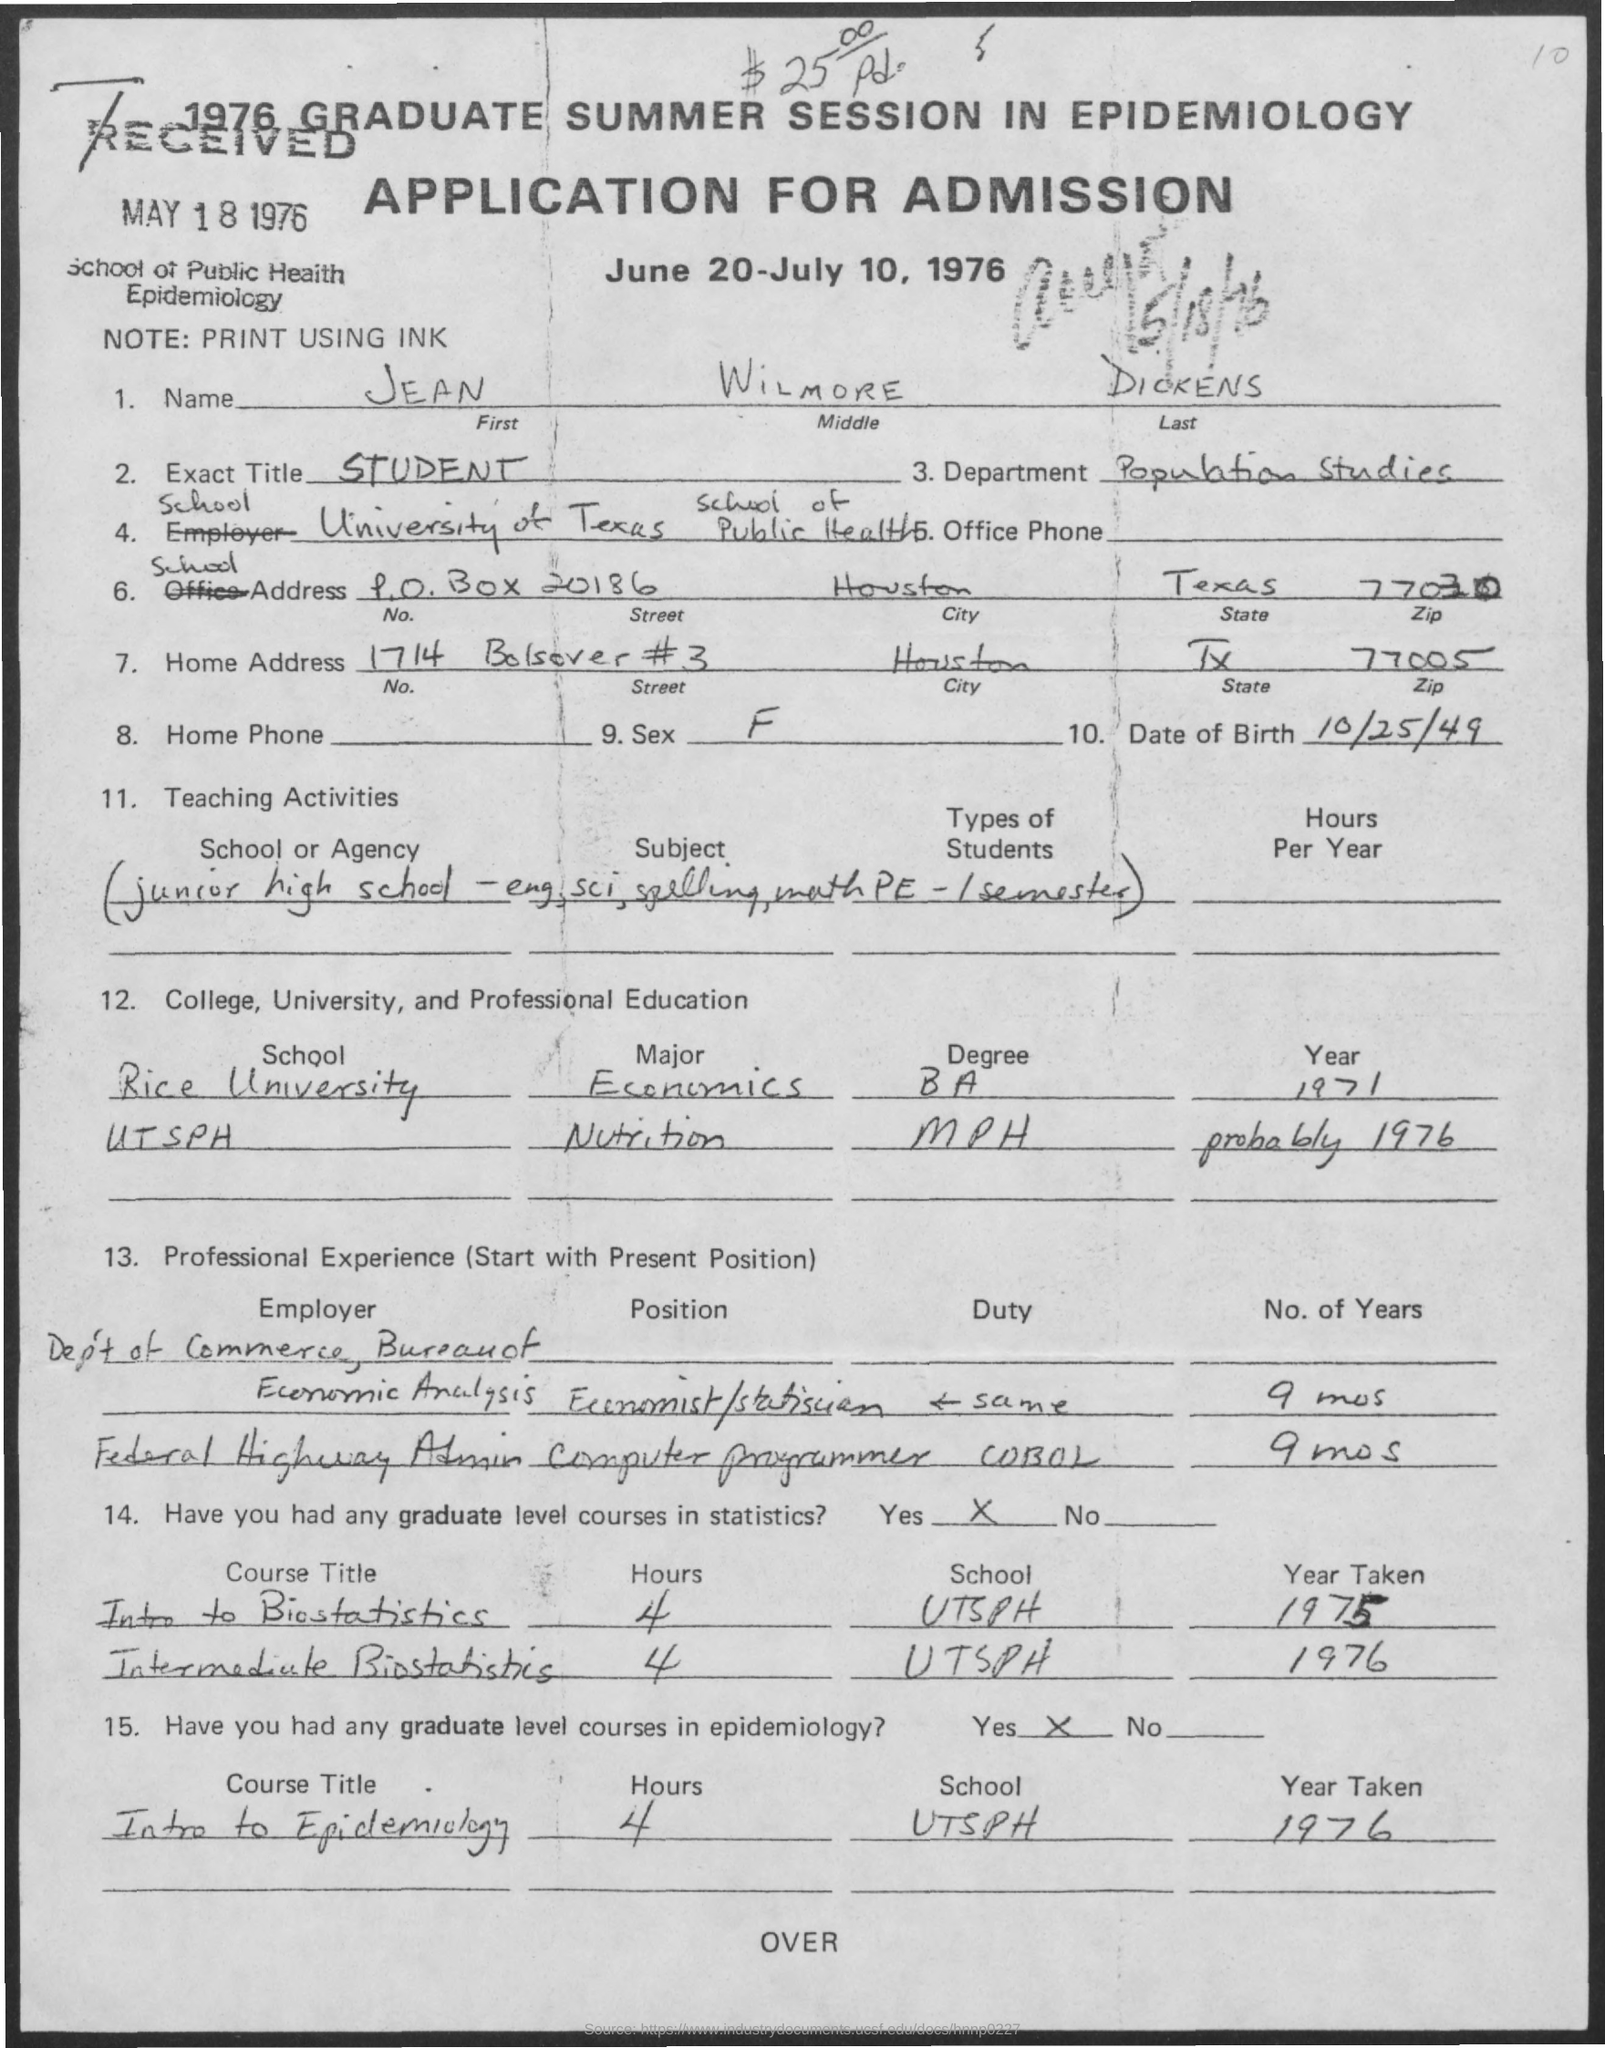Does the application state if the applicant has taken any graduate-level courses in statistics or epidemiology? The applicant affirms having taken graduate-level courses in both statistics and epidemiology. Specifically, 'Intro to Biostatistics' and 'Intermediate Biostatistics', each for 4 hours at UTSPH in the year 1976. Furthermore, the applicant has taken 'Intro to Epidemiology', a 4-hour course at the same institution in 1976. 